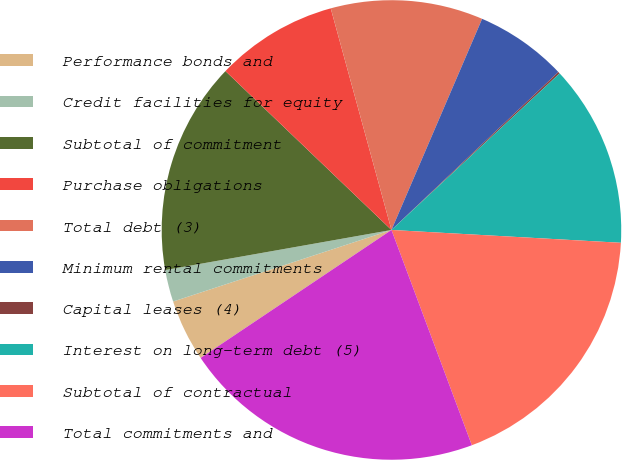<chart> <loc_0><loc_0><loc_500><loc_500><pie_chart><fcel>Performance bonds and<fcel>Credit facilities for equity<fcel>Subtotal of commitment<fcel>Purchase obligations<fcel>Total debt (3)<fcel>Minimum rental commitments<fcel>Capital leases (4)<fcel>Interest on long-term debt (5)<fcel>Subtotal of contractual<fcel>Total commitments and<nl><fcel>4.36%<fcel>2.25%<fcel>14.94%<fcel>8.59%<fcel>10.71%<fcel>6.48%<fcel>0.13%<fcel>12.82%<fcel>18.42%<fcel>21.28%<nl></chart> 